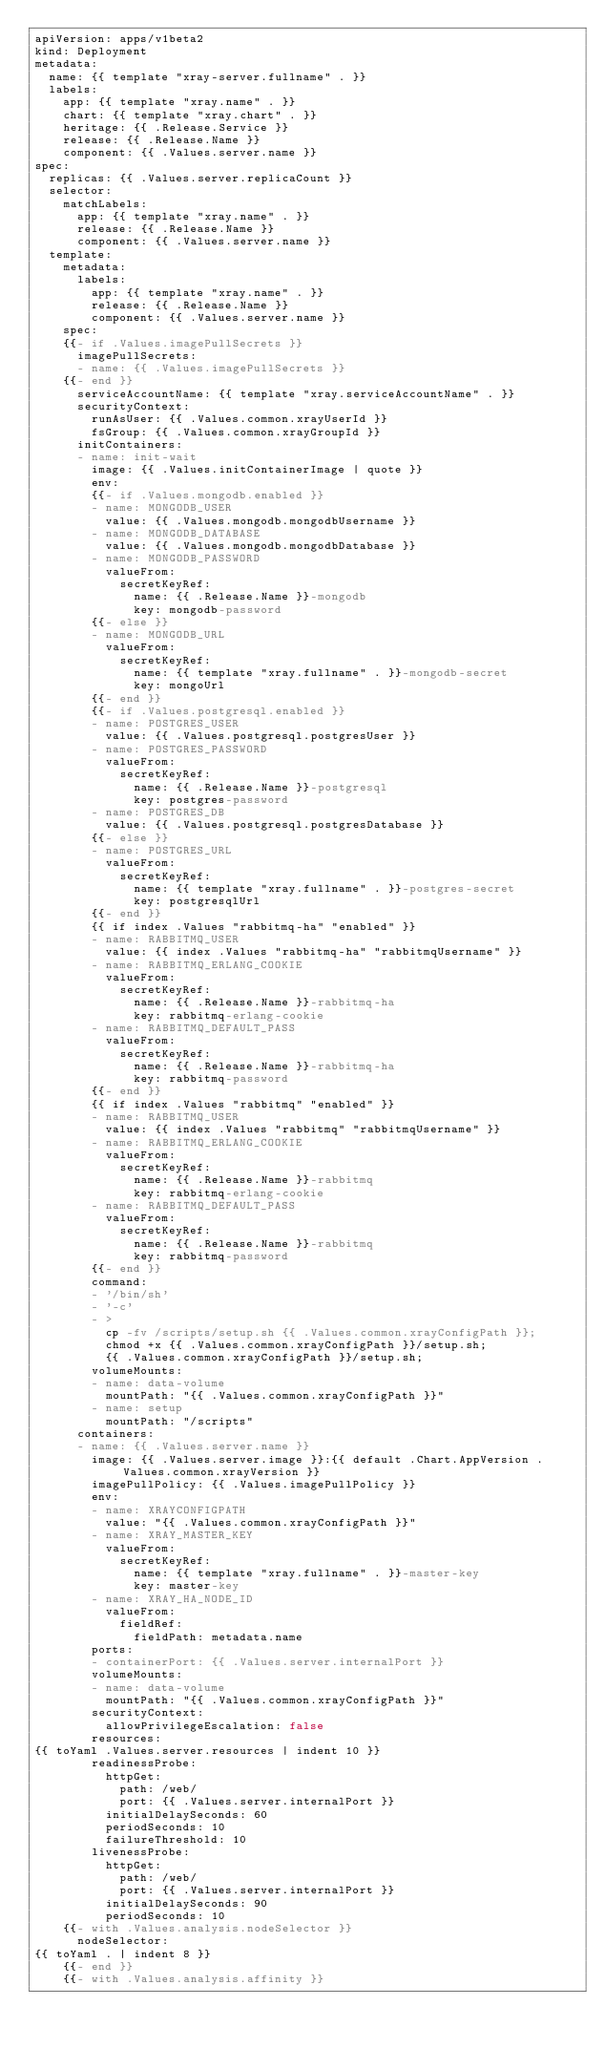<code> <loc_0><loc_0><loc_500><loc_500><_YAML_>apiVersion: apps/v1beta2
kind: Deployment
metadata:
  name: {{ template "xray-server.fullname" . }}
  labels:
    app: {{ template "xray.name" . }}
    chart: {{ template "xray.chart" . }}
    heritage: {{ .Release.Service }}
    release: {{ .Release.Name }}
    component: {{ .Values.server.name }}
spec:
  replicas: {{ .Values.server.replicaCount }}
  selector:
    matchLabels:
      app: {{ template "xray.name" . }}
      release: {{ .Release.Name }}
      component: {{ .Values.server.name }}
  template:
    metadata:
      labels:
        app: {{ template "xray.name" . }}
        release: {{ .Release.Name }}
        component: {{ .Values.server.name }}
    spec:
    {{- if .Values.imagePullSecrets }}
      imagePullSecrets:
      - name: {{ .Values.imagePullSecrets }}
    {{- end }}
      serviceAccountName: {{ template "xray.serviceAccountName" . }}
      securityContext:
        runAsUser: {{ .Values.common.xrayUserId }}
        fsGroup: {{ .Values.common.xrayGroupId }}
      initContainers:
      - name: init-wait
        image: {{ .Values.initContainerImage | quote }}
        env:
        {{- if .Values.mongodb.enabled }}
        - name: MONGODB_USER
          value: {{ .Values.mongodb.mongodbUsername }}
        - name: MONGODB_DATABASE
          value: {{ .Values.mongodb.mongodbDatabase }}
        - name: MONGODB_PASSWORD
          valueFrom:
            secretKeyRef:
              name: {{ .Release.Name }}-mongodb
              key: mongodb-password
        {{- else }}
        - name: MONGODB_URL
          valueFrom:
            secretKeyRef:
              name: {{ template "xray.fullname" . }}-mongodb-secret
              key: mongoUrl
        {{- end }}
        {{- if .Values.postgresql.enabled }}
        - name: POSTGRES_USER
          value: {{ .Values.postgresql.postgresUser }}
        - name: POSTGRES_PASSWORD
          valueFrom:
            secretKeyRef:
              name: {{ .Release.Name }}-postgresql
              key: postgres-password
        - name: POSTGRES_DB
          value: {{ .Values.postgresql.postgresDatabase }}
        {{- else }}
        - name: POSTGRES_URL
          valueFrom:
            secretKeyRef:
              name: {{ template "xray.fullname" . }}-postgres-secret
              key: postgresqlUrl
        {{- end }}
        {{ if index .Values "rabbitmq-ha" "enabled" }}
        - name: RABBITMQ_USER
          value: {{ index .Values "rabbitmq-ha" "rabbitmqUsername" }}
        - name: RABBITMQ_ERLANG_COOKIE
          valueFrom:
            secretKeyRef:
              name: {{ .Release.Name }}-rabbitmq-ha
              key: rabbitmq-erlang-cookie
        - name: RABBITMQ_DEFAULT_PASS
          valueFrom:
            secretKeyRef:
              name: {{ .Release.Name }}-rabbitmq-ha
              key: rabbitmq-password
        {{- end }}
        {{ if index .Values "rabbitmq" "enabled" }}
        - name: RABBITMQ_USER
          value: {{ index .Values "rabbitmq" "rabbitmqUsername" }}
        - name: RABBITMQ_ERLANG_COOKIE
          valueFrom:
            secretKeyRef:
              name: {{ .Release.Name }}-rabbitmq
              key: rabbitmq-erlang-cookie
        - name: RABBITMQ_DEFAULT_PASS
          valueFrom:
            secretKeyRef:
              name: {{ .Release.Name }}-rabbitmq
              key: rabbitmq-password
        {{- end }}
        command:
        - '/bin/sh'
        - '-c'
        - >
          cp -fv /scripts/setup.sh {{ .Values.common.xrayConfigPath }};
          chmod +x {{ .Values.common.xrayConfigPath }}/setup.sh;
          {{ .Values.common.xrayConfigPath }}/setup.sh;
        volumeMounts:
        - name: data-volume
          mountPath: "{{ .Values.common.xrayConfigPath }}"
        - name: setup
          mountPath: "/scripts"
      containers:
      - name: {{ .Values.server.name }}
        image: {{ .Values.server.image }}:{{ default .Chart.AppVersion .Values.common.xrayVersion }}
        imagePullPolicy: {{ .Values.imagePullPolicy }}
        env:
        - name: XRAYCONFIGPATH
          value: "{{ .Values.common.xrayConfigPath }}"
        - name: XRAY_MASTER_KEY
          valueFrom:
            secretKeyRef:
              name: {{ template "xray.fullname" . }}-master-key
              key: master-key
        - name: XRAY_HA_NODE_ID
          valueFrom:
            fieldRef:
              fieldPath: metadata.name
        ports:
        - containerPort: {{ .Values.server.internalPort }}
        volumeMounts:
        - name: data-volume
          mountPath: "{{ .Values.common.xrayConfigPath }}"
        securityContext:
          allowPrivilegeEscalation: false
        resources:
{{ toYaml .Values.server.resources | indent 10 }}
        readinessProbe:
          httpGet:
            path: /web/
            port: {{ .Values.server.internalPort }}
          initialDelaySeconds: 60
          periodSeconds: 10
          failureThreshold: 10
        livenessProbe:
          httpGet:
            path: /web/
            port: {{ .Values.server.internalPort }}
          initialDelaySeconds: 90
          periodSeconds: 10
    {{- with .Values.analysis.nodeSelector }}
      nodeSelector:
{{ toYaml . | indent 8 }}
    {{- end }}
    {{- with .Values.analysis.affinity }}</code> 